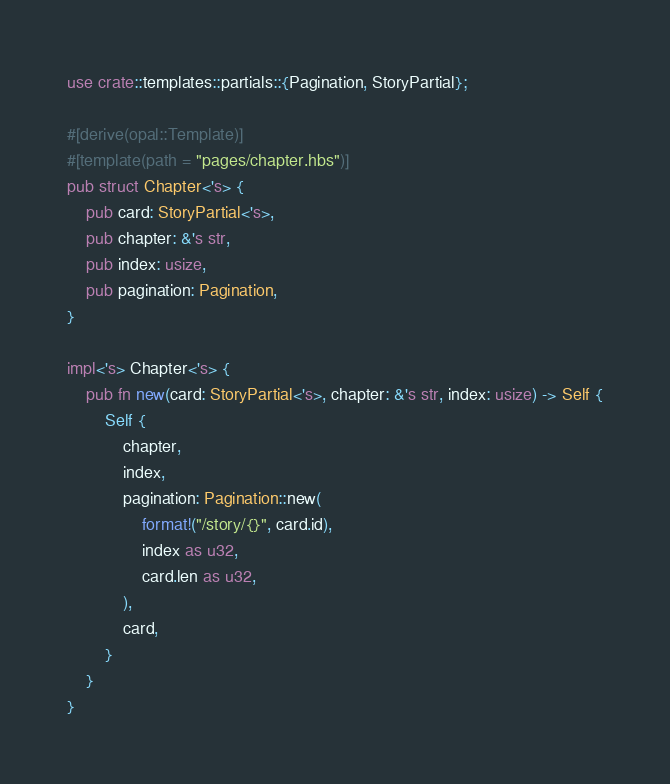Convert code to text. <code><loc_0><loc_0><loc_500><loc_500><_Rust_>use crate::templates::partials::{Pagination, StoryPartial};

#[derive(opal::Template)]
#[template(path = "pages/chapter.hbs")]
pub struct Chapter<'s> {
    pub card: StoryPartial<'s>,
    pub chapter: &'s str,
    pub index: usize,
    pub pagination: Pagination,
}

impl<'s> Chapter<'s> {
    pub fn new(card: StoryPartial<'s>, chapter: &'s str, index: usize) -> Self {
        Self {
            chapter,
            index,
            pagination: Pagination::new(
                format!("/story/{}", card.id),
                index as u32,
                card.len as u32,
            ),
            card,
        }
    }
}
</code> 